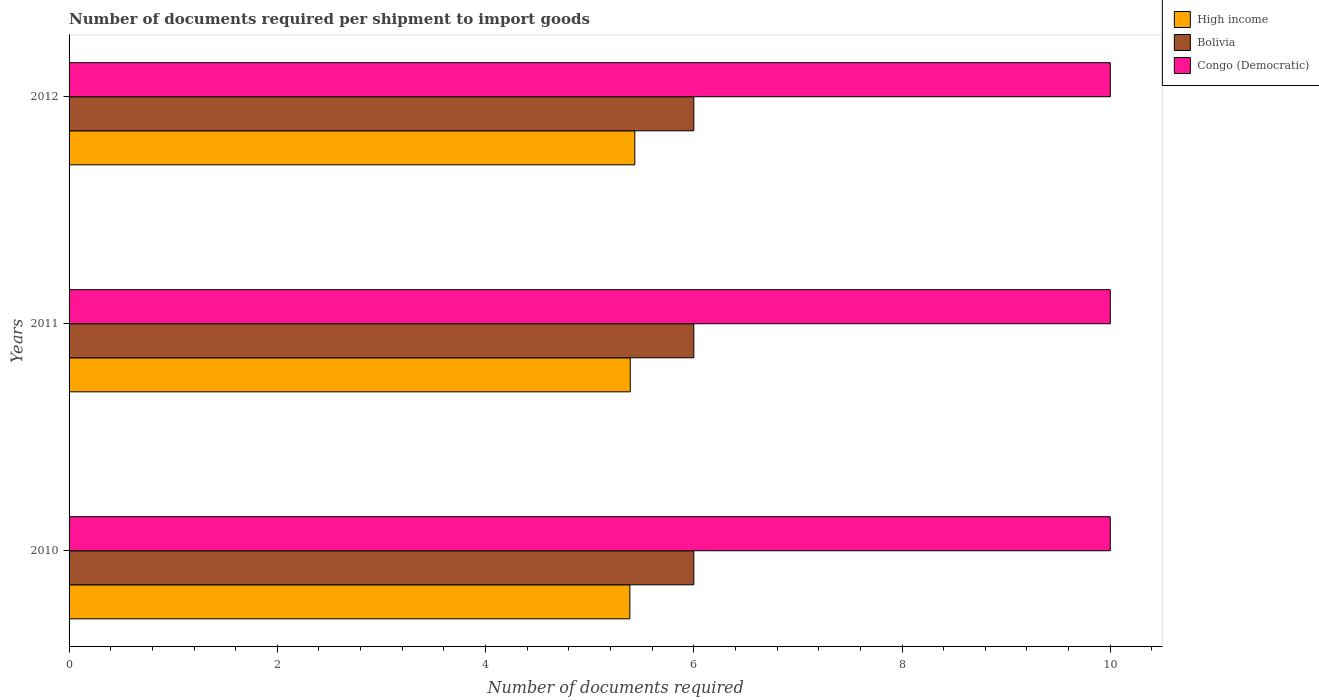How many different coloured bars are there?
Your response must be concise. 3. Are the number of bars per tick equal to the number of legend labels?
Your answer should be compact. Yes. Are the number of bars on each tick of the Y-axis equal?
Offer a very short reply. Yes. How many bars are there on the 2nd tick from the bottom?
Keep it short and to the point. 3. What is the label of the 3rd group of bars from the top?
Offer a very short reply. 2010. In how many cases, is the number of bars for a given year not equal to the number of legend labels?
Your answer should be very brief. 0. What is the number of documents required per shipment to import goods in Congo (Democratic) in 2012?
Provide a short and direct response. 10. Across all years, what is the minimum number of documents required per shipment to import goods in Bolivia?
Provide a succinct answer. 6. In which year was the number of documents required per shipment to import goods in Bolivia minimum?
Provide a succinct answer. 2010. What is the total number of documents required per shipment to import goods in Bolivia in the graph?
Provide a succinct answer. 18. What is the difference between the number of documents required per shipment to import goods in High income in 2010 and the number of documents required per shipment to import goods in Bolivia in 2011?
Keep it short and to the point. -0.61. What is the average number of documents required per shipment to import goods in High income per year?
Ensure brevity in your answer.  5.4. In the year 2011, what is the difference between the number of documents required per shipment to import goods in High income and number of documents required per shipment to import goods in Bolivia?
Provide a succinct answer. -0.61. In how many years, is the number of documents required per shipment to import goods in Congo (Democratic) greater than 6 ?
Offer a very short reply. 3. What is the ratio of the number of documents required per shipment to import goods in High income in 2011 to that in 2012?
Offer a very short reply. 0.99. What is the difference between the highest and the second highest number of documents required per shipment to import goods in Bolivia?
Provide a succinct answer. 0. In how many years, is the number of documents required per shipment to import goods in Bolivia greater than the average number of documents required per shipment to import goods in Bolivia taken over all years?
Provide a succinct answer. 0. What does the 1st bar from the top in 2011 represents?
Offer a terse response. Congo (Democratic). What does the 3rd bar from the bottom in 2010 represents?
Keep it short and to the point. Congo (Democratic). How many bars are there?
Provide a succinct answer. 9. Are all the bars in the graph horizontal?
Make the answer very short. Yes. Where does the legend appear in the graph?
Provide a short and direct response. Top right. How many legend labels are there?
Give a very brief answer. 3. How are the legend labels stacked?
Keep it short and to the point. Vertical. What is the title of the graph?
Make the answer very short. Number of documents required per shipment to import goods. What is the label or title of the X-axis?
Offer a terse response. Number of documents required. What is the label or title of the Y-axis?
Keep it short and to the point. Years. What is the Number of documents required of High income in 2010?
Provide a short and direct response. 5.39. What is the Number of documents required in Congo (Democratic) in 2010?
Offer a terse response. 10. What is the Number of documents required in High income in 2011?
Provide a succinct answer. 5.39. What is the Number of documents required in High income in 2012?
Your response must be concise. 5.43. What is the Number of documents required in Bolivia in 2012?
Offer a very short reply. 6. What is the Number of documents required in Congo (Democratic) in 2012?
Ensure brevity in your answer.  10. Across all years, what is the maximum Number of documents required in High income?
Your answer should be very brief. 5.43. Across all years, what is the maximum Number of documents required of Bolivia?
Your answer should be very brief. 6. Across all years, what is the minimum Number of documents required in High income?
Your response must be concise. 5.39. Across all years, what is the minimum Number of documents required in Bolivia?
Ensure brevity in your answer.  6. Across all years, what is the minimum Number of documents required of Congo (Democratic)?
Ensure brevity in your answer.  10. What is the total Number of documents required of High income in the graph?
Keep it short and to the point. 16.21. What is the total Number of documents required in Bolivia in the graph?
Offer a terse response. 18. What is the difference between the Number of documents required in High income in 2010 and that in 2011?
Provide a short and direct response. -0. What is the difference between the Number of documents required in Bolivia in 2010 and that in 2011?
Offer a very short reply. 0. What is the difference between the Number of documents required in High income in 2010 and that in 2012?
Make the answer very short. -0.05. What is the difference between the Number of documents required in High income in 2011 and that in 2012?
Make the answer very short. -0.04. What is the difference between the Number of documents required of Bolivia in 2011 and that in 2012?
Offer a very short reply. 0. What is the difference between the Number of documents required in High income in 2010 and the Number of documents required in Bolivia in 2011?
Provide a short and direct response. -0.61. What is the difference between the Number of documents required of High income in 2010 and the Number of documents required of Congo (Democratic) in 2011?
Offer a terse response. -4.61. What is the difference between the Number of documents required of High income in 2010 and the Number of documents required of Bolivia in 2012?
Provide a succinct answer. -0.61. What is the difference between the Number of documents required in High income in 2010 and the Number of documents required in Congo (Democratic) in 2012?
Ensure brevity in your answer.  -4.61. What is the difference between the Number of documents required in Bolivia in 2010 and the Number of documents required in Congo (Democratic) in 2012?
Ensure brevity in your answer.  -4. What is the difference between the Number of documents required in High income in 2011 and the Number of documents required in Bolivia in 2012?
Your answer should be compact. -0.61. What is the difference between the Number of documents required of High income in 2011 and the Number of documents required of Congo (Democratic) in 2012?
Your answer should be very brief. -4.61. What is the average Number of documents required of High income per year?
Your response must be concise. 5.4. What is the average Number of documents required in Congo (Democratic) per year?
Provide a succinct answer. 10. In the year 2010, what is the difference between the Number of documents required in High income and Number of documents required in Bolivia?
Keep it short and to the point. -0.61. In the year 2010, what is the difference between the Number of documents required of High income and Number of documents required of Congo (Democratic)?
Keep it short and to the point. -4.61. In the year 2011, what is the difference between the Number of documents required of High income and Number of documents required of Bolivia?
Your response must be concise. -0.61. In the year 2011, what is the difference between the Number of documents required of High income and Number of documents required of Congo (Democratic)?
Your response must be concise. -4.61. In the year 2012, what is the difference between the Number of documents required in High income and Number of documents required in Bolivia?
Ensure brevity in your answer.  -0.57. In the year 2012, what is the difference between the Number of documents required of High income and Number of documents required of Congo (Democratic)?
Your response must be concise. -4.57. In the year 2012, what is the difference between the Number of documents required of Bolivia and Number of documents required of Congo (Democratic)?
Provide a succinct answer. -4. What is the ratio of the Number of documents required of High income in 2010 to that in 2011?
Keep it short and to the point. 1. What is the ratio of the Number of documents required in Bolivia in 2010 to that in 2011?
Offer a terse response. 1. What is the ratio of the Number of documents required in High income in 2010 to that in 2012?
Offer a terse response. 0.99. What is the ratio of the Number of documents required of Bolivia in 2010 to that in 2012?
Offer a very short reply. 1. What is the ratio of the Number of documents required in Congo (Democratic) in 2011 to that in 2012?
Your answer should be compact. 1. What is the difference between the highest and the second highest Number of documents required in High income?
Provide a succinct answer. 0.04. What is the difference between the highest and the lowest Number of documents required in High income?
Give a very brief answer. 0.05. 